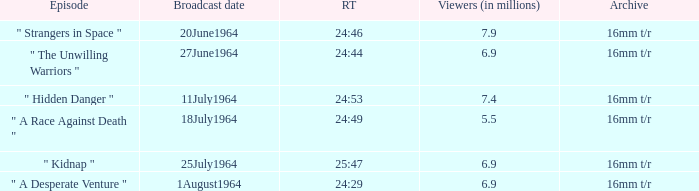How many viewers were there on 1august1964? 6.9. 